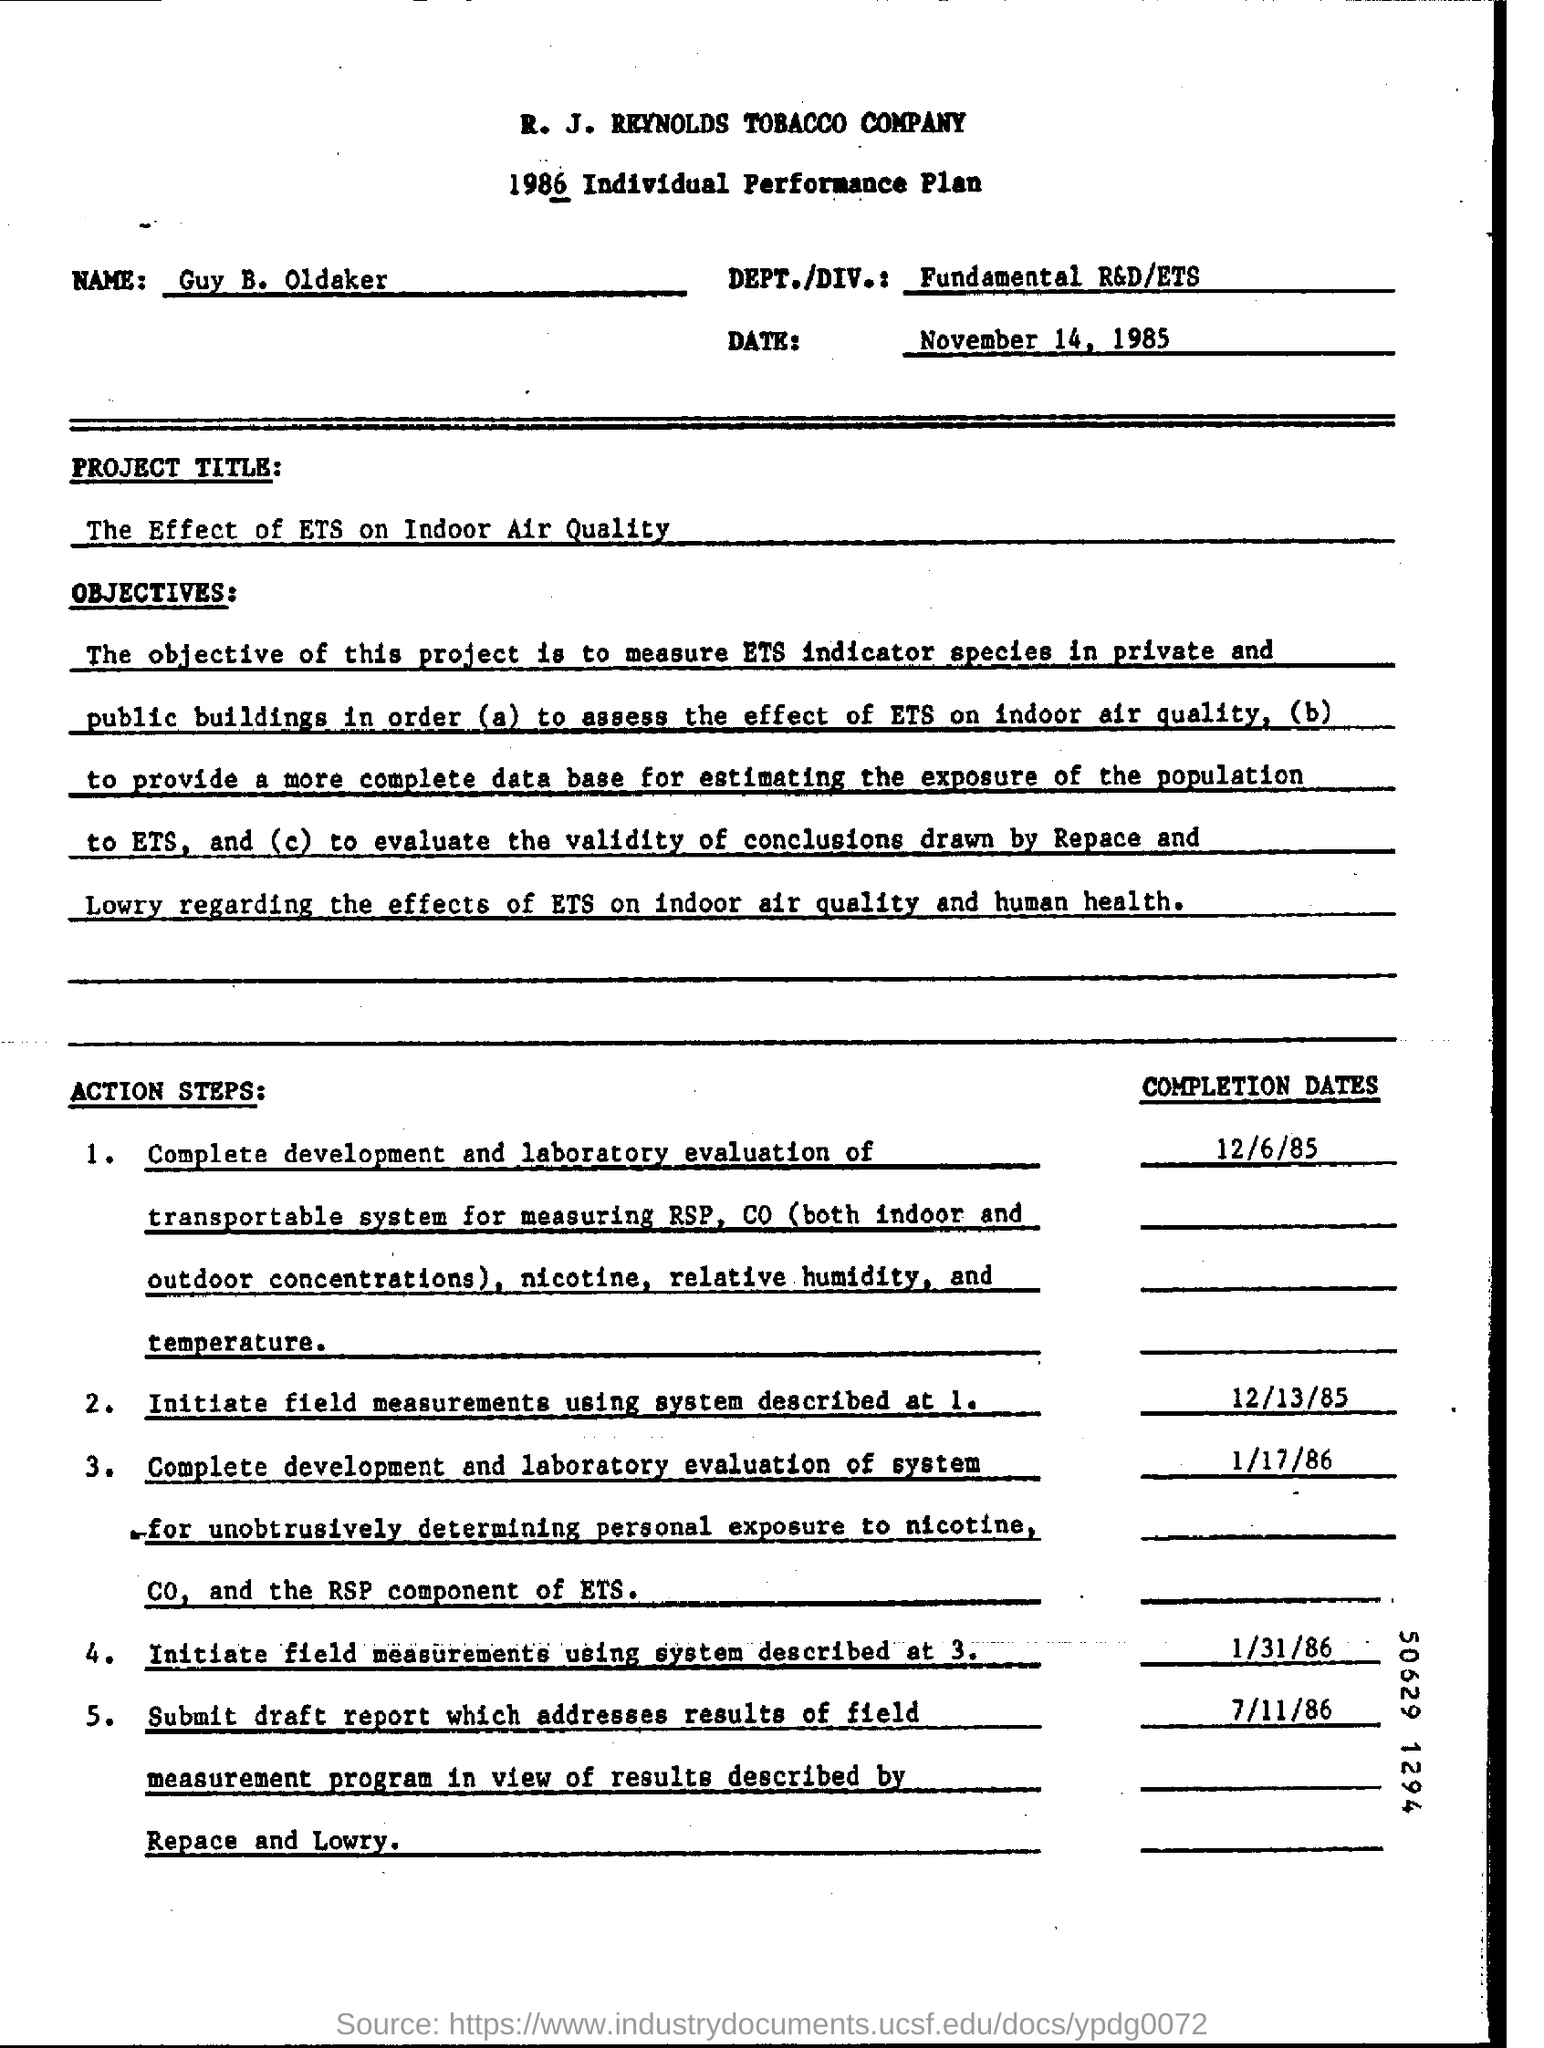List a handful of essential elements in this visual. The document in question is a 1986 Individual Performance Plan. The department is fundamental research and development/environmental technology and sustainability. The document is dated November 14, 1985. The name given is Guy B. Oldaker. The project title is "The Effect of ETS on Indoor Air Quality. 